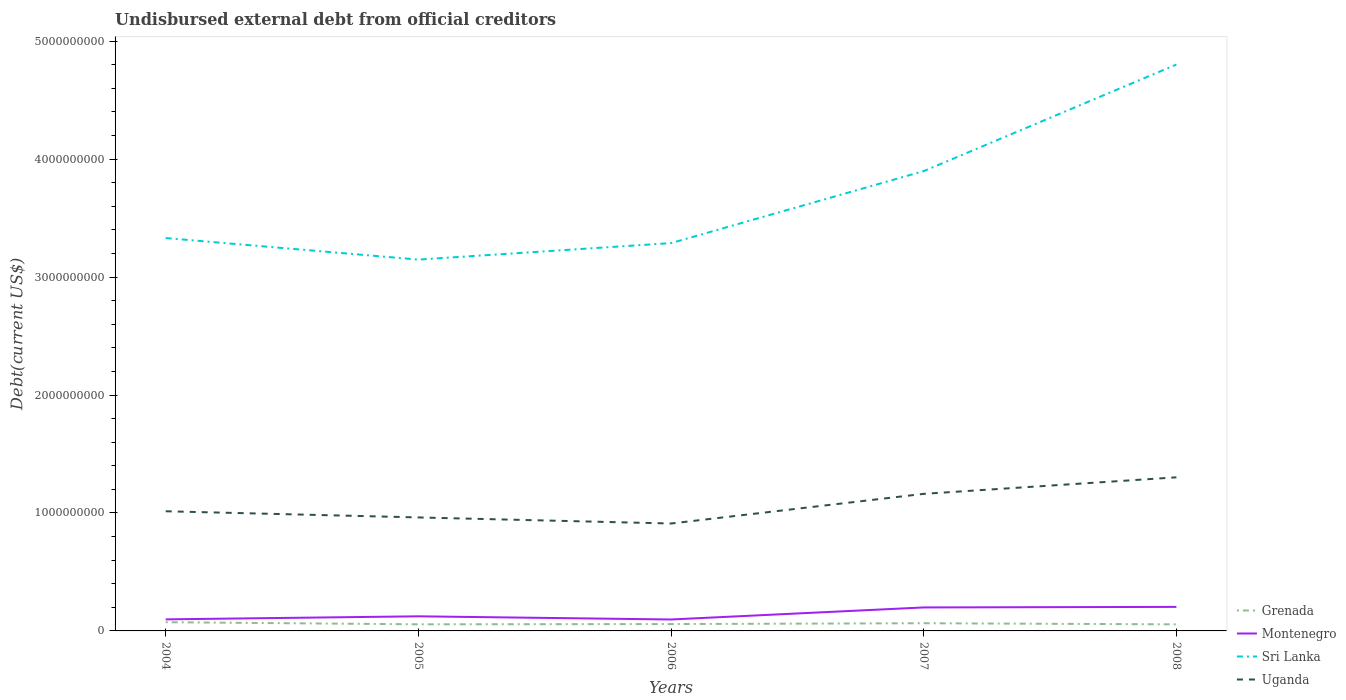How many different coloured lines are there?
Offer a very short reply. 4. Across all years, what is the maximum total debt in Grenada?
Make the answer very short. 5.57e+07. What is the total total debt in Uganda in the graph?
Offer a very short reply. -1.48e+08. What is the difference between the highest and the second highest total debt in Grenada?
Ensure brevity in your answer.  1.82e+07. What is the difference between the highest and the lowest total debt in Uganda?
Provide a short and direct response. 2. Is the total debt in Montenegro strictly greater than the total debt in Grenada over the years?
Make the answer very short. No. How many years are there in the graph?
Offer a terse response. 5. What is the difference between two consecutive major ticks on the Y-axis?
Give a very brief answer. 1.00e+09. How are the legend labels stacked?
Provide a succinct answer. Vertical. What is the title of the graph?
Your answer should be very brief. Undisbursed external debt from official creditors. What is the label or title of the X-axis?
Ensure brevity in your answer.  Years. What is the label or title of the Y-axis?
Ensure brevity in your answer.  Debt(current US$). What is the Debt(current US$) of Grenada in 2004?
Your answer should be very brief. 7.40e+07. What is the Debt(current US$) in Montenegro in 2004?
Offer a very short reply. 9.81e+07. What is the Debt(current US$) in Sri Lanka in 2004?
Your answer should be compact. 3.33e+09. What is the Debt(current US$) of Uganda in 2004?
Keep it short and to the point. 1.01e+09. What is the Debt(current US$) in Grenada in 2005?
Offer a terse response. 5.61e+07. What is the Debt(current US$) in Montenegro in 2005?
Keep it short and to the point. 1.24e+08. What is the Debt(current US$) of Sri Lanka in 2005?
Ensure brevity in your answer.  3.15e+09. What is the Debt(current US$) in Uganda in 2005?
Make the answer very short. 9.62e+08. What is the Debt(current US$) in Grenada in 2006?
Offer a very short reply. 5.82e+07. What is the Debt(current US$) of Montenegro in 2006?
Your answer should be compact. 9.70e+07. What is the Debt(current US$) of Sri Lanka in 2006?
Offer a terse response. 3.29e+09. What is the Debt(current US$) in Uganda in 2006?
Offer a terse response. 9.11e+08. What is the Debt(current US$) in Grenada in 2007?
Offer a terse response. 6.52e+07. What is the Debt(current US$) of Montenegro in 2007?
Provide a short and direct response. 1.99e+08. What is the Debt(current US$) of Sri Lanka in 2007?
Offer a terse response. 3.90e+09. What is the Debt(current US$) in Uganda in 2007?
Make the answer very short. 1.16e+09. What is the Debt(current US$) of Grenada in 2008?
Your answer should be compact. 5.57e+07. What is the Debt(current US$) of Montenegro in 2008?
Provide a short and direct response. 2.04e+08. What is the Debt(current US$) in Sri Lanka in 2008?
Ensure brevity in your answer.  4.80e+09. What is the Debt(current US$) in Uganda in 2008?
Offer a very short reply. 1.30e+09. Across all years, what is the maximum Debt(current US$) in Grenada?
Your response must be concise. 7.40e+07. Across all years, what is the maximum Debt(current US$) in Montenegro?
Offer a terse response. 2.04e+08. Across all years, what is the maximum Debt(current US$) of Sri Lanka?
Provide a succinct answer. 4.80e+09. Across all years, what is the maximum Debt(current US$) of Uganda?
Ensure brevity in your answer.  1.30e+09. Across all years, what is the minimum Debt(current US$) in Grenada?
Provide a short and direct response. 5.57e+07. Across all years, what is the minimum Debt(current US$) of Montenegro?
Your answer should be compact. 9.70e+07. Across all years, what is the minimum Debt(current US$) of Sri Lanka?
Offer a terse response. 3.15e+09. Across all years, what is the minimum Debt(current US$) in Uganda?
Your response must be concise. 9.11e+08. What is the total Debt(current US$) of Grenada in the graph?
Keep it short and to the point. 3.09e+08. What is the total Debt(current US$) of Montenegro in the graph?
Your response must be concise. 7.22e+08. What is the total Debt(current US$) in Sri Lanka in the graph?
Keep it short and to the point. 1.85e+1. What is the total Debt(current US$) of Uganda in the graph?
Your response must be concise. 5.35e+09. What is the difference between the Debt(current US$) of Grenada in 2004 and that in 2005?
Provide a succinct answer. 1.79e+07. What is the difference between the Debt(current US$) in Montenegro in 2004 and that in 2005?
Keep it short and to the point. -2.58e+07. What is the difference between the Debt(current US$) of Sri Lanka in 2004 and that in 2005?
Provide a short and direct response. 1.83e+08. What is the difference between the Debt(current US$) of Uganda in 2004 and that in 2005?
Offer a terse response. 5.22e+07. What is the difference between the Debt(current US$) of Grenada in 2004 and that in 2006?
Give a very brief answer. 1.57e+07. What is the difference between the Debt(current US$) in Montenegro in 2004 and that in 2006?
Your answer should be compact. 1.08e+06. What is the difference between the Debt(current US$) in Sri Lanka in 2004 and that in 2006?
Give a very brief answer. 4.29e+07. What is the difference between the Debt(current US$) in Uganda in 2004 and that in 2006?
Ensure brevity in your answer.  1.04e+08. What is the difference between the Debt(current US$) of Grenada in 2004 and that in 2007?
Your response must be concise. 8.72e+06. What is the difference between the Debt(current US$) of Montenegro in 2004 and that in 2007?
Provide a short and direct response. -1.01e+08. What is the difference between the Debt(current US$) in Sri Lanka in 2004 and that in 2007?
Make the answer very short. -5.68e+08. What is the difference between the Debt(current US$) of Uganda in 2004 and that in 2007?
Keep it short and to the point. -1.48e+08. What is the difference between the Debt(current US$) of Grenada in 2004 and that in 2008?
Your answer should be very brief. 1.82e+07. What is the difference between the Debt(current US$) in Montenegro in 2004 and that in 2008?
Give a very brief answer. -1.06e+08. What is the difference between the Debt(current US$) in Sri Lanka in 2004 and that in 2008?
Provide a succinct answer. -1.47e+09. What is the difference between the Debt(current US$) of Uganda in 2004 and that in 2008?
Provide a short and direct response. -2.88e+08. What is the difference between the Debt(current US$) in Grenada in 2005 and that in 2006?
Offer a very short reply. -2.14e+06. What is the difference between the Debt(current US$) in Montenegro in 2005 and that in 2006?
Give a very brief answer. 2.69e+07. What is the difference between the Debt(current US$) of Sri Lanka in 2005 and that in 2006?
Offer a very short reply. -1.40e+08. What is the difference between the Debt(current US$) of Uganda in 2005 and that in 2006?
Ensure brevity in your answer.  5.15e+07. What is the difference between the Debt(current US$) in Grenada in 2005 and that in 2007?
Your response must be concise. -9.16e+06. What is the difference between the Debt(current US$) of Montenegro in 2005 and that in 2007?
Your answer should be very brief. -7.52e+07. What is the difference between the Debt(current US$) in Sri Lanka in 2005 and that in 2007?
Your answer should be very brief. -7.50e+08. What is the difference between the Debt(current US$) of Uganda in 2005 and that in 2007?
Make the answer very short. -2.00e+08. What is the difference between the Debt(current US$) of Montenegro in 2005 and that in 2008?
Your answer should be compact. -7.98e+07. What is the difference between the Debt(current US$) in Sri Lanka in 2005 and that in 2008?
Your response must be concise. -1.65e+09. What is the difference between the Debt(current US$) in Uganda in 2005 and that in 2008?
Your response must be concise. -3.40e+08. What is the difference between the Debt(current US$) in Grenada in 2006 and that in 2007?
Your answer should be very brief. -7.02e+06. What is the difference between the Debt(current US$) in Montenegro in 2006 and that in 2007?
Offer a terse response. -1.02e+08. What is the difference between the Debt(current US$) of Sri Lanka in 2006 and that in 2007?
Your answer should be very brief. -6.10e+08. What is the difference between the Debt(current US$) of Uganda in 2006 and that in 2007?
Give a very brief answer. -2.51e+08. What is the difference between the Debt(current US$) in Grenada in 2006 and that in 2008?
Give a very brief answer. 2.49e+06. What is the difference between the Debt(current US$) of Montenegro in 2006 and that in 2008?
Keep it short and to the point. -1.07e+08. What is the difference between the Debt(current US$) of Sri Lanka in 2006 and that in 2008?
Ensure brevity in your answer.  -1.51e+09. What is the difference between the Debt(current US$) in Uganda in 2006 and that in 2008?
Your answer should be very brief. -3.92e+08. What is the difference between the Debt(current US$) in Grenada in 2007 and that in 2008?
Make the answer very short. 9.50e+06. What is the difference between the Debt(current US$) in Montenegro in 2007 and that in 2008?
Keep it short and to the point. -4.64e+06. What is the difference between the Debt(current US$) of Sri Lanka in 2007 and that in 2008?
Offer a very short reply. -9.03e+08. What is the difference between the Debt(current US$) of Uganda in 2007 and that in 2008?
Your answer should be compact. -1.40e+08. What is the difference between the Debt(current US$) of Grenada in 2004 and the Debt(current US$) of Montenegro in 2005?
Ensure brevity in your answer.  -4.99e+07. What is the difference between the Debt(current US$) in Grenada in 2004 and the Debt(current US$) in Sri Lanka in 2005?
Your answer should be compact. -3.07e+09. What is the difference between the Debt(current US$) of Grenada in 2004 and the Debt(current US$) of Uganda in 2005?
Provide a succinct answer. -8.88e+08. What is the difference between the Debt(current US$) of Montenegro in 2004 and the Debt(current US$) of Sri Lanka in 2005?
Your answer should be compact. -3.05e+09. What is the difference between the Debt(current US$) of Montenegro in 2004 and the Debt(current US$) of Uganda in 2005?
Provide a short and direct response. -8.64e+08. What is the difference between the Debt(current US$) of Sri Lanka in 2004 and the Debt(current US$) of Uganda in 2005?
Offer a very short reply. 2.37e+09. What is the difference between the Debt(current US$) of Grenada in 2004 and the Debt(current US$) of Montenegro in 2006?
Your response must be concise. -2.31e+07. What is the difference between the Debt(current US$) of Grenada in 2004 and the Debt(current US$) of Sri Lanka in 2006?
Offer a very short reply. -3.21e+09. What is the difference between the Debt(current US$) in Grenada in 2004 and the Debt(current US$) in Uganda in 2006?
Your answer should be compact. -8.37e+08. What is the difference between the Debt(current US$) in Montenegro in 2004 and the Debt(current US$) in Sri Lanka in 2006?
Provide a short and direct response. -3.19e+09. What is the difference between the Debt(current US$) in Montenegro in 2004 and the Debt(current US$) in Uganda in 2006?
Provide a short and direct response. -8.13e+08. What is the difference between the Debt(current US$) in Sri Lanka in 2004 and the Debt(current US$) in Uganda in 2006?
Your answer should be compact. 2.42e+09. What is the difference between the Debt(current US$) of Grenada in 2004 and the Debt(current US$) of Montenegro in 2007?
Offer a terse response. -1.25e+08. What is the difference between the Debt(current US$) of Grenada in 2004 and the Debt(current US$) of Sri Lanka in 2007?
Your response must be concise. -3.82e+09. What is the difference between the Debt(current US$) in Grenada in 2004 and the Debt(current US$) in Uganda in 2007?
Make the answer very short. -1.09e+09. What is the difference between the Debt(current US$) in Montenegro in 2004 and the Debt(current US$) in Sri Lanka in 2007?
Your answer should be very brief. -3.80e+09. What is the difference between the Debt(current US$) of Montenegro in 2004 and the Debt(current US$) of Uganda in 2007?
Keep it short and to the point. -1.06e+09. What is the difference between the Debt(current US$) of Sri Lanka in 2004 and the Debt(current US$) of Uganda in 2007?
Your answer should be very brief. 2.17e+09. What is the difference between the Debt(current US$) of Grenada in 2004 and the Debt(current US$) of Montenegro in 2008?
Your response must be concise. -1.30e+08. What is the difference between the Debt(current US$) in Grenada in 2004 and the Debt(current US$) in Sri Lanka in 2008?
Provide a succinct answer. -4.73e+09. What is the difference between the Debt(current US$) in Grenada in 2004 and the Debt(current US$) in Uganda in 2008?
Provide a short and direct response. -1.23e+09. What is the difference between the Debt(current US$) of Montenegro in 2004 and the Debt(current US$) of Sri Lanka in 2008?
Provide a succinct answer. -4.70e+09. What is the difference between the Debt(current US$) in Montenegro in 2004 and the Debt(current US$) in Uganda in 2008?
Your answer should be compact. -1.20e+09. What is the difference between the Debt(current US$) of Sri Lanka in 2004 and the Debt(current US$) of Uganda in 2008?
Your response must be concise. 2.03e+09. What is the difference between the Debt(current US$) in Grenada in 2005 and the Debt(current US$) in Montenegro in 2006?
Your answer should be very brief. -4.09e+07. What is the difference between the Debt(current US$) of Grenada in 2005 and the Debt(current US$) of Sri Lanka in 2006?
Provide a short and direct response. -3.23e+09. What is the difference between the Debt(current US$) in Grenada in 2005 and the Debt(current US$) in Uganda in 2006?
Your answer should be compact. -8.55e+08. What is the difference between the Debt(current US$) in Montenegro in 2005 and the Debt(current US$) in Sri Lanka in 2006?
Offer a terse response. -3.16e+09. What is the difference between the Debt(current US$) in Montenegro in 2005 and the Debt(current US$) in Uganda in 2006?
Give a very brief answer. -7.87e+08. What is the difference between the Debt(current US$) of Sri Lanka in 2005 and the Debt(current US$) of Uganda in 2006?
Your answer should be compact. 2.24e+09. What is the difference between the Debt(current US$) in Grenada in 2005 and the Debt(current US$) in Montenegro in 2007?
Your response must be concise. -1.43e+08. What is the difference between the Debt(current US$) of Grenada in 2005 and the Debt(current US$) of Sri Lanka in 2007?
Make the answer very short. -3.84e+09. What is the difference between the Debt(current US$) in Grenada in 2005 and the Debt(current US$) in Uganda in 2007?
Keep it short and to the point. -1.11e+09. What is the difference between the Debt(current US$) in Montenegro in 2005 and the Debt(current US$) in Sri Lanka in 2007?
Give a very brief answer. -3.77e+09. What is the difference between the Debt(current US$) in Montenegro in 2005 and the Debt(current US$) in Uganda in 2007?
Ensure brevity in your answer.  -1.04e+09. What is the difference between the Debt(current US$) of Sri Lanka in 2005 and the Debt(current US$) of Uganda in 2007?
Offer a very short reply. 1.99e+09. What is the difference between the Debt(current US$) in Grenada in 2005 and the Debt(current US$) in Montenegro in 2008?
Your answer should be very brief. -1.48e+08. What is the difference between the Debt(current US$) in Grenada in 2005 and the Debt(current US$) in Sri Lanka in 2008?
Provide a short and direct response. -4.75e+09. What is the difference between the Debt(current US$) of Grenada in 2005 and the Debt(current US$) of Uganda in 2008?
Your answer should be compact. -1.25e+09. What is the difference between the Debt(current US$) of Montenegro in 2005 and the Debt(current US$) of Sri Lanka in 2008?
Provide a short and direct response. -4.68e+09. What is the difference between the Debt(current US$) of Montenegro in 2005 and the Debt(current US$) of Uganda in 2008?
Provide a short and direct response. -1.18e+09. What is the difference between the Debt(current US$) in Sri Lanka in 2005 and the Debt(current US$) in Uganda in 2008?
Offer a very short reply. 1.85e+09. What is the difference between the Debt(current US$) of Grenada in 2006 and the Debt(current US$) of Montenegro in 2007?
Your response must be concise. -1.41e+08. What is the difference between the Debt(current US$) in Grenada in 2006 and the Debt(current US$) in Sri Lanka in 2007?
Provide a short and direct response. -3.84e+09. What is the difference between the Debt(current US$) of Grenada in 2006 and the Debt(current US$) of Uganda in 2007?
Provide a short and direct response. -1.10e+09. What is the difference between the Debt(current US$) in Montenegro in 2006 and the Debt(current US$) in Sri Lanka in 2007?
Keep it short and to the point. -3.80e+09. What is the difference between the Debt(current US$) of Montenegro in 2006 and the Debt(current US$) of Uganda in 2007?
Your answer should be very brief. -1.07e+09. What is the difference between the Debt(current US$) of Sri Lanka in 2006 and the Debt(current US$) of Uganda in 2007?
Offer a very short reply. 2.13e+09. What is the difference between the Debt(current US$) of Grenada in 2006 and the Debt(current US$) of Montenegro in 2008?
Your answer should be very brief. -1.46e+08. What is the difference between the Debt(current US$) in Grenada in 2006 and the Debt(current US$) in Sri Lanka in 2008?
Provide a succinct answer. -4.74e+09. What is the difference between the Debt(current US$) in Grenada in 2006 and the Debt(current US$) in Uganda in 2008?
Offer a terse response. -1.24e+09. What is the difference between the Debt(current US$) of Montenegro in 2006 and the Debt(current US$) of Sri Lanka in 2008?
Provide a succinct answer. -4.70e+09. What is the difference between the Debt(current US$) of Montenegro in 2006 and the Debt(current US$) of Uganda in 2008?
Give a very brief answer. -1.21e+09. What is the difference between the Debt(current US$) in Sri Lanka in 2006 and the Debt(current US$) in Uganda in 2008?
Provide a short and direct response. 1.99e+09. What is the difference between the Debt(current US$) of Grenada in 2007 and the Debt(current US$) of Montenegro in 2008?
Your answer should be compact. -1.38e+08. What is the difference between the Debt(current US$) in Grenada in 2007 and the Debt(current US$) in Sri Lanka in 2008?
Offer a terse response. -4.74e+09. What is the difference between the Debt(current US$) of Grenada in 2007 and the Debt(current US$) of Uganda in 2008?
Offer a very short reply. -1.24e+09. What is the difference between the Debt(current US$) of Montenegro in 2007 and the Debt(current US$) of Sri Lanka in 2008?
Offer a terse response. -4.60e+09. What is the difference between the Debt(current US$) of Montenegro in 2007 and the Debt(current US$) of Uganda in 2008?
Ensure brevity in your answer.  -1.10e+09. What is the difference between the Debt(current US$) of Sri Lanka in 2007 and the Debt(current US$) of Uganda in 2008?
Your answer should be very brief. 2.60e+09. What is the average Debt(current US$) in Grenada per year?
Keep it short and to the point. 6.19e+07. What is the average Debt(current US$) in Montenegro per year?
Keep it short and to the point. 1.44e+08. What is the average Debt(current US$) of Sri Lanka per year?
Ensure brevity in your answer.  3.69e+09. What is the average Debt(current US$) in Uganda per year?
Make the answer very short. 1.07e+09. In the year 2004, what is the difference between the Debt(current US$) of Grenada and Debt(current US$) of Montenegro?
Provide a short and direct response. -2.41e+07. In the year 2004, what is the difference between the Debt(current US$) in Grenada and Debt(current US$) in Sri Lanka?
Provide a short and direct response. -3.26e+09. In the year 2004, what is the difference between the Debt(current US$) in Grenada and Debt(current US$) in Uganda?
Your answer should be compact. -9.41e+08. In the year 2004, what is the difference between the Debt(current US$) of Montenegro and Debt(current US$) of Sri Lanka?
Provide a succinct answer. -3.23e+09. In the year 2004, what is the difference between the Debt(current US$) in Montenegro and Debt(current US$) in Uganda?
Ensure brevity in your answer.  -9.16e+08. In the year 2004, what is the difference between the Debt(current US$) in Sri Lanka and Debt(current US$) in Uganda?
Keep it short and to the point. 2.32e+09. In the year 2005, what is the difference between the Debt(current US$) of Grenada and Debt(current US$) of Montenegro?
Offer a very short reply. -6.78e+07. In the year 2005, what is the difference between the Debt(current US$) of Grenada and Debt(current US$) of Sri Lanka?
Offer a terse response. -3.09e+09. In the year 2005, what is the difference between the Debt(current US$) in Grenada and Debt(current US$) in Uganda?
Keep it short and to the point. -9.06e+08. In the year 2005, what is the difference between the Debt(current US$) of Montenegro and Debt(current US$) of Sri Lanka?
Provide a short and direct response. -3.02e+09. In the year 2005, what is the difference between the Debt(current US$) in Montenegro and Debt(current US$) in Uganda?
Provide a succinct answer. -8.38e+08. In the year 2005, what is the difference between the Debt(current US$) in Sri Lanka and Debt(current US$) in Uganda?
Provide a short and direct response. 2.19e+09. In the year 2006, what is the difference between the Debt(current US$) of Grenada and Debt(current US$) of Montenegro?
Your answer should be compact. -3.88e+07. In the year 2006, what is the difference between the Debt(current US$) of Grenada and Debt(current US$) of Sri Lanka?
Your response must be concise. -3.23e+09. In the year 2006, what is the difference between the Debt(current US$) in Grenada and Debt(current US$) in Uganda?
Your answer should be very brief. -8.52e+08. In the year 2006, what is the difference between the Debt(current US$) in Montenegro and Debt(current US$) in Sri Lanka?
Offer a very short reply. -3.19e+09. In the year 2006, what is the difference between the Debt(current US$) of Montenegro and Debt(current US$) of Uganda?
Make the answer very short. -8.14e+08. In the year 2006, what is the difference between the Debt(current US$) in Sri Lanka and Debt(current US$) in Uganda?
Provide a short and direct response. 2.38e+09. In the year 2007, what is the difference between the Debt(current US$) of Grenada and Debt(current US$) of Montenegro?
Give a very brief answer. -1.34e+08. In the year 2007, what is the difference between the Debt(current US$) in Grenada and Debt(current US$) in Sri Lanka?
Offer a very short reply. -3.83e+09. In the year 2007, what is the difference between the Debt(current US$) in Grenada and Debt(current US$) in Uganda?
Your response must be concise. -1.10e+09. In the year 2007, what is the difference between the Debt(current US$) in Montenegro and Debt(current US$) in Sri Lanka?
Offer a terse response. -3.70e+09. In the year 2007, what is the difference between the Debt(current US$) of Montenegro and Debt(current US$) of Uganda?
Keep it short and to the point. -9.63e+08. In the year 2007, what is the difference between the Debt(current US$) of Sri Lanka and Debt(current US$) of Uganda?
Keep it short and to the point. 2.74e+09. In the year 2008, what is the difference between the Debt(current US$) in Grenada and Debt(current US$) in Montenegro?
Your response must be concise. -1.48e+08. In the year 2008, what is the difference between the Debt(current US$) of Grenada and Debt(current US$) of Sri Lanka?
Your answer should be very brief. -4.75e+09. In the year 2008, what is the difference between the Debt(current US$) in Grenada and Debt(current US$) in Uganda?
Your response must be concise. -1.25e+09. In the year 2008, what is the difference between the Debt(current US$) in Montenegro and Debt(current US$) in Sri Lanka?
Give a very brief answer. -4.60e+09. In the year 2008, what is the difference between the Debt(current US$) in Montenegro and Debt(current US$) in Uganda?
Give a very brief answer. -1.10e+09. In the year 2008, what is the difference between the Debt(current US$) of Sri Lanka and Debt(current US$) of Uganda?
Offer a terse response. 3.50e+09. What is the ratio of the Debt(current US$) of Grenada in 2004 to that in 2005?
Ensure brevity in your answer.  1.32. What is the ratio of the Debt(current US$) of Montenegro in 2004 to that in 2005?
Offer a very short reply. 0.79. What is the ratio of the Debt(current US$) of Sri Lanka in 2004 to that in 2005?
Offer a terse response. 1.06. What is the ratio of the Debt(current US$) in Uganda in 2004 to that in 2005?
Offer a very short reply. 1.05. What is the ratio of the Debt(current US$) of Grenada in 2004 to that in 2006?
Your answer should be compact. 1.27. What is the ratio of the Debt(current US$) in Montenegro in 2004 to that in 2006?
Offer a very short reply. 1.01. What is the ratio of the Debt(current US$) in Uganda in 2004 to that in 2006?
Your answer should be very brief. 1.11. What is the ratio of the Debt(current US$) of Grenada in 2004 to that in 2007?
Offer a very short reply. 1.13. What is the ratio of the Debt(current US$) in Montenegro in 2004 to that in 2007?
Give a very brief answer. 0.49. What is the ratio of the Debt(current US$) of Sri Lanka in 2004 to that in 2007?
Your answer should be very brief. 0.85. What is the ratio of the Debt(current US$) of Uganda in 2004 to that in 2007?
Your response must be concise. 0.87. What is the ratio of the Debt(current US$) of Grenada in 2004 to that in 2008?
Offer a very short reply. 1.33. What is the ratio of the Debt(current US$) in Montenegro in 2004 to that in 2008?
Keep it short and to the point. 0.48. What is the ratio of the Debt(current US$) of Sri Lanka in 2004 to that in 2008?
Ensure brevity in your answer.  0.69. What is the ratio of the Debt(current US$) of Uganda in 2004 to that in 2008?
Offer a terse response. 0.78. What is the ratio of the Debt(current US$) in Grenada in 2005 to that in 2006?
Your response must be concise. 0.96. What is the ratio of the Debt(current US$) of Montenegro in 2005 to that in 2006?
Provide a short and direct response. 1.28. What is the ratio of the Debt(current US$) in Sri Lanka in 2005 to that in 2006?
Your answer should be very brief. 0.96. What is the ratio of the Debt(current US$) of Uganda in 2005 to that in 2006?
Provide a succinct answer. 1.06. What is the ratio of the Debt(current US$) in Grenada in 2005 to that in 2007?
Provide a succinct answer. 0.86. What is the ratio of the Debt(current US$) of Montenegro in 2005 to that in 2007?
Offer a terse response. 0.62. What is the ratio of the Debt(current US$) of Sri Lanka in 2005 to that in 2007?
Give a very brief answer. 0.81. What is the ratio of the Debt(current US$) of Uganda in 2005 to that in 2007?
Your response must be concise. 0.83. What is the ratio of the Debt(current US$) in Grenada in 2005 to that in 2008?
Make the answer very short. 1.01. What is the ratio of the Debt(current US$) of Montenegro in 2005 to that in 2008?
Give a very brief answer. 0.61. What is the ratio of the Debt(current US$) in Sri Lanka in 2005 to that in 2008?
Keep it short and to the point. 0.66. What is the ratio of the Debt(current US$) in Uganda in 2005 to that in 2008?
Provide a short and direct response. 0.74. What is the ratio of the Debt(current US$) in Grenada in 2006 to that in 2007?
Offer a terse response. 0.89. What is the ratio of the Debt(current US$) of Montenegro in 2006 to that in 2007?
Make the answer very short. 0.49. What is the ratio of the Debt(current US$) in Sri Lanka in 2006 to that in 2007?
Provide a short and direct response. 0.84. What is the ratio of the Debt(current US$) of Uganda in 2006 to that in 2007?
Offer a very short reply. 0.78. What is the ratio of the Debt(current US$) in Grenada in 2006 to that in 2008?
Your response must be concise. 1.04. What is the ratio of the Debt(current US$) in Montenegro in 2006 to that in 2008?
Your response must be concise. 0.48. What is the ratio of the Debt(current US$) in Sri Lanka in 2006 to that in 2008?
Your answer should be compact. 0.68. What is the ratio of the Debt(current US$) in Uganda in 2006 to that in 2008?
Provide a succinct answer. 0.7. What is the ratio of the Debt(current US$) of Grenada in 2007 to that in 2008?
Your response must be concise. 1.17. What is the ratio of the Debt(current US$) of Montenegro in 2007 to that in 2008?
Your response must be concise. 0.98. What is the ratio of the Debt(current US$) in Sri Lanka in 2007 to that in 2008?
Ensure brevity in your answer.  0.81. What is the ratio of the Debt(current US$) of Uganda in 2007 to that in 2008?
Your answer should be compact. 0.89. What is the difference between the highest and the second highest Debt(current US$) in Grenada?
Give a very brief answer. 8.72e+06. What is the difference between the highest and the second highest Debt(current US$) in Montenegro?
Your response must be concise. 4.64e+06. What is the difference between the highest and the second highest Debt(current US$) in Sri Lanka?
Offer a very short reply. 9.03e+08. What is the difference between the highest and the second highest Debt(current US$) of Uganda?
Keep it short and to the point. 1.40e+08. What is the difference between the highest and the lowest Debt(current US$) in Grenada?
Provide a short and direct response. 1.82e+07. What is the difference between the highest and the lowest Debt(current US$) in Montenegro?
Offer a terse response. 1.07e+08. What is the difference between the highest and the lowest Debt(current US$) of Sri Lanka?
Give a very brief answer. 1.65e+09. What is the difference between the highest and the lowest Debt(current US$) of Uganda?
Offer a terse response. 3.92e+08. 